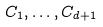Convert formula to latex. <formula><loc_0><loc_0><loc_500><loc_500>C _ { 1 } , \dots , C _ { d + 1 }</formula> 